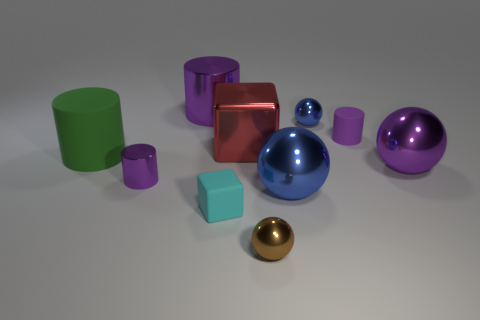Subtract all purple cylinders. How many were subtracted if there are1purple cylinders left? 2 Subtract all yellow blocks. How many purple cylinders are left? 3 Subtract all cubes. How many objects are left? 8 Add 4 small cylinders. How many small cylinders are left? 6 Add 7 tiny matte cylinders. How many tiny matte cylinders exist? 8 Subtract 0 green balls. How many objects are left? 10 Subtract all big objects. Subtract all large blue metal objects. How many objects are left? 4 